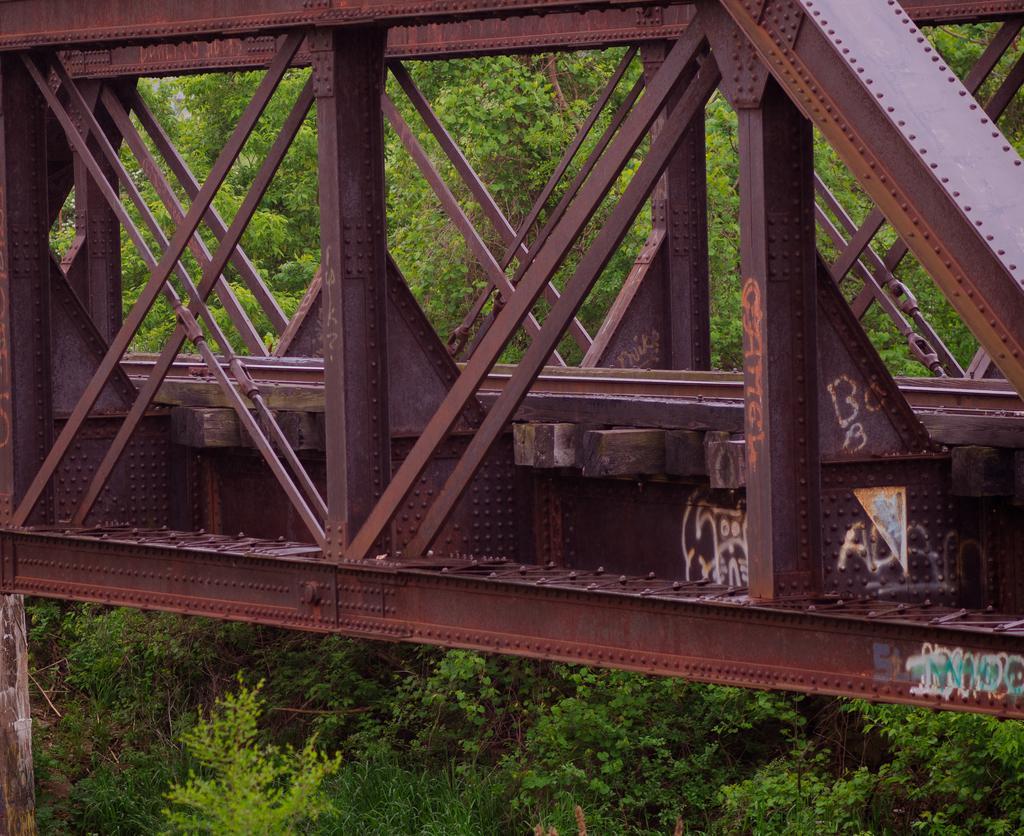Please provide a concise description of this image. In this image we can see a bridge, poles and texts written on the bridge on the right side. In the background there are trees and plants on the ground. 